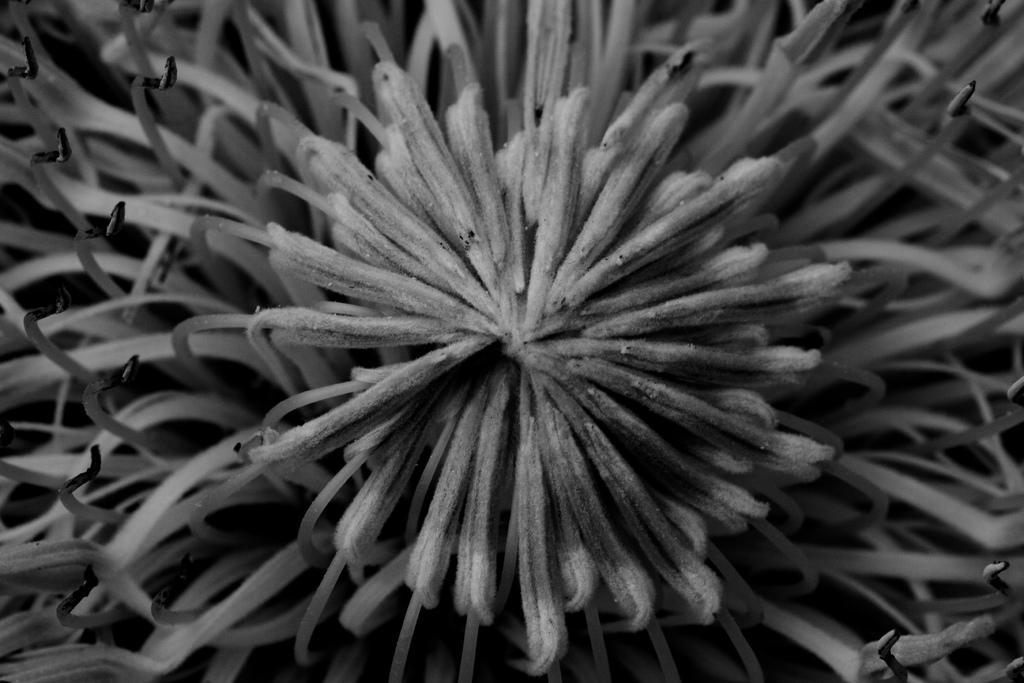Could you give a brief overview of what you see in this image? This is a black and white picture and in this picture we can see a flower. 